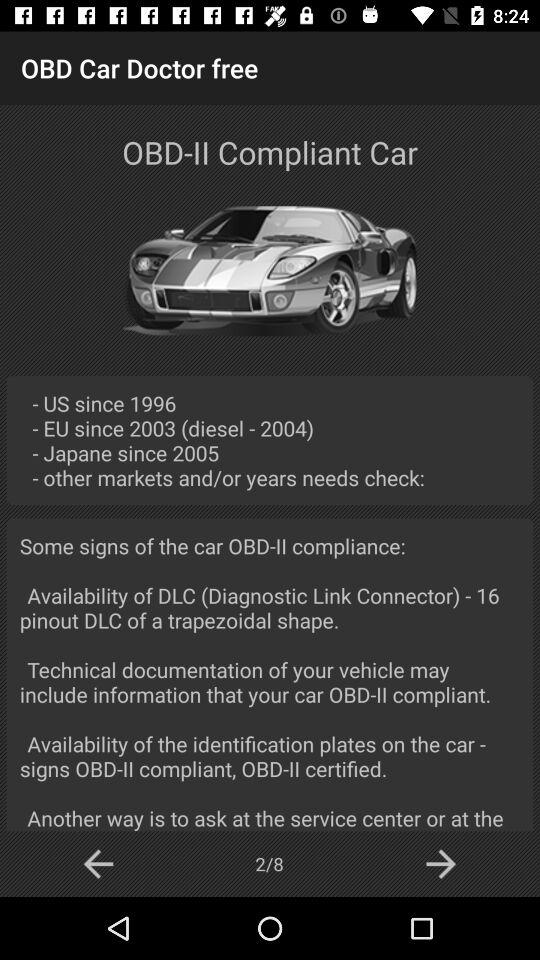Since when are OBD-II Compliant cars on the US market? OBD-II compliant cars have been on the US market since 1996. 